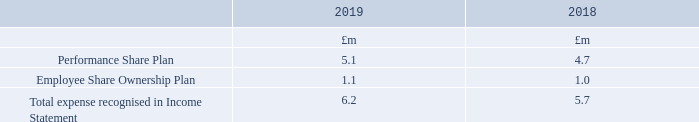Share-based payments
Disclosures of the share-based payments offered to employees are set out below. More detail on each scheme is given in the Annual Report on Remuneration 2019 on pages 102 to 132. The charge to the Income Statement in respect of share-based payments is made up as follows:
Where can more details on each shares payment scheme be found? In the annual report on remuneration 2019 on pages 102 to 132. What is the total expense recognised in Income Statement in 2019?
Answer scale should be: million. 6.2. What are the types of plans for the share-based payments offered to employees in the table? Performance share plan, employee share ownership plan. In which year was the amount for Employee Share Ownership Plan value larger? 1.1>1.0
Answer: 2019. What was the change in the amount for Performance Share Plan from 2018 to 2019?
Answer scale should be: million. 5.1-4.7
Answer: 0.4. What was the percentage change in the amount for Performance Share Plan from 2018 to 2019?
Answer scale should be: percent. (5.1-4.7)/4.7
Answer: 8.51. 